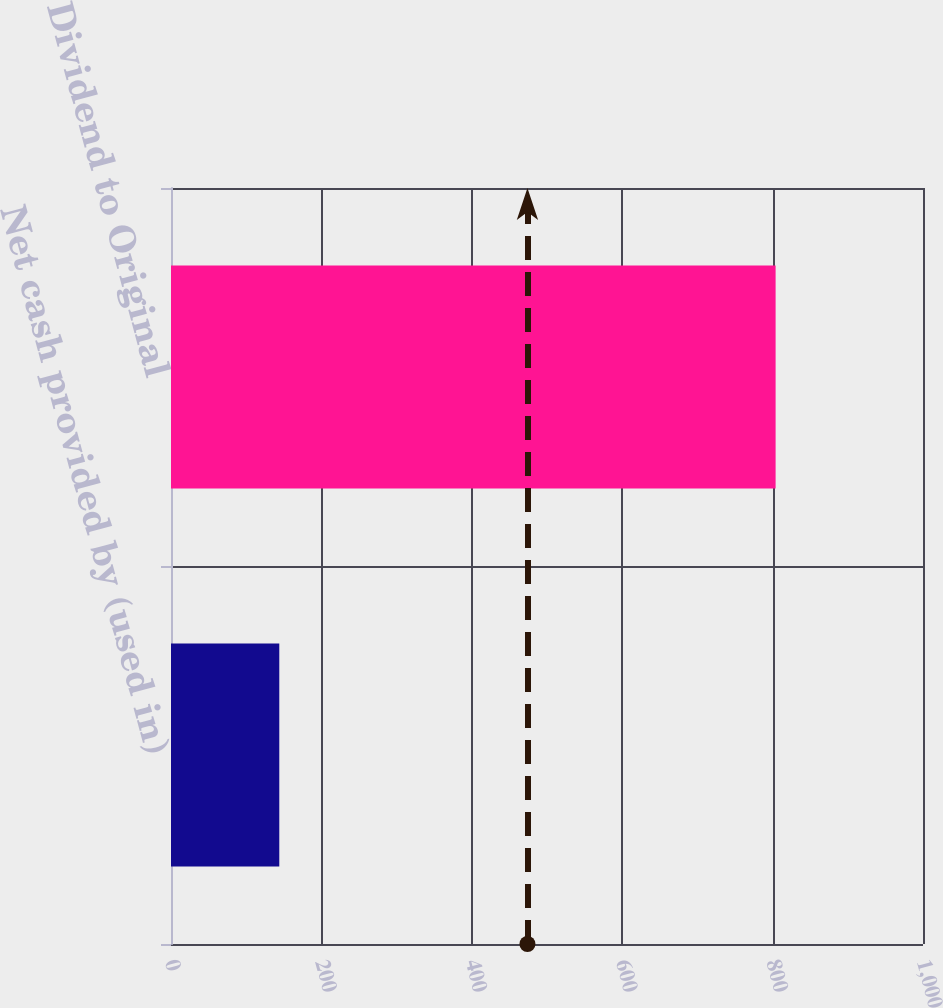<chart> <loc_0><loc_0><loc_500><loc_500><bar_chart><fcel>Net cash provided by (used in)<fcel>Dividend to Original<nl><fcel>144<fcel>804<nl></chart> 